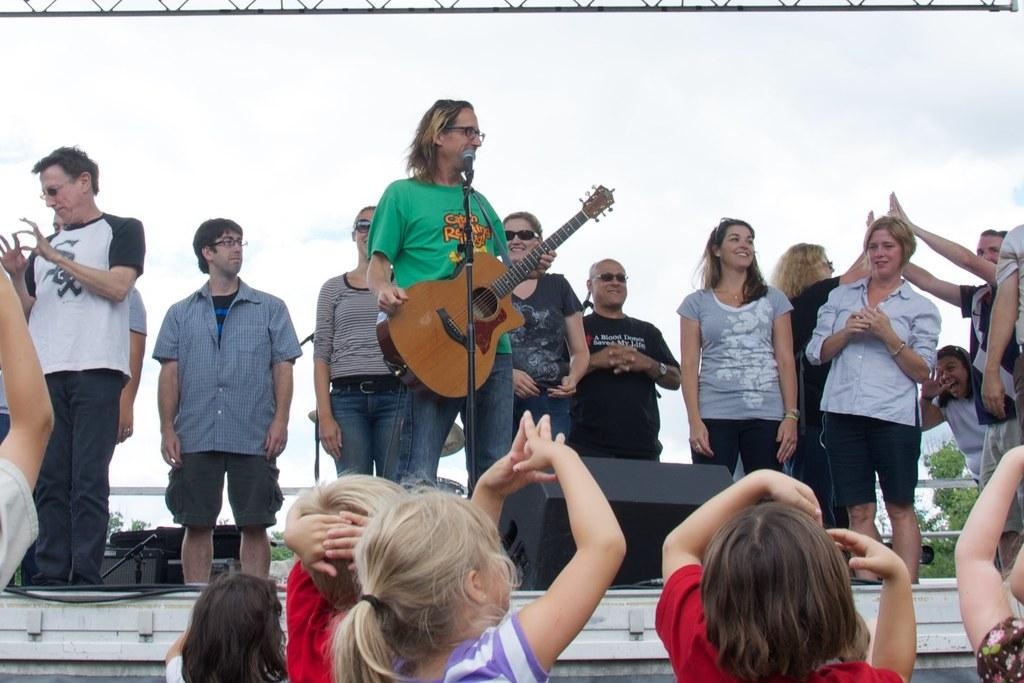What are the persons in the image doing? One of the persons is playing a guitar. Can you identify the instrument being played? The instrument is identified as a mike, which is likely a typo and should be "guitar." What can be seen in the background of the image? There is sky and trees visible in the background of the image. What type of servant can be seen attending to the persons in the image? There is no servant present in the image. What magical powers do the trees possess in the image? The trees in the image do not possess any magical powers; they are simply part of the natural background. 